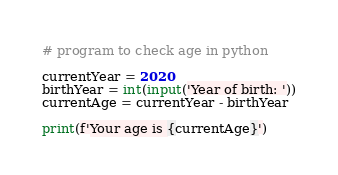Convert code to text. <code><loc_0><loc_0><loc_500><loc_500><_Python_># program to check age in python

currentYear = 2020
birthYear = int(input('Year of birth: '))
currentAge = currentYear - birthYear

print(f'Your age is {currentAge}')
</code> 